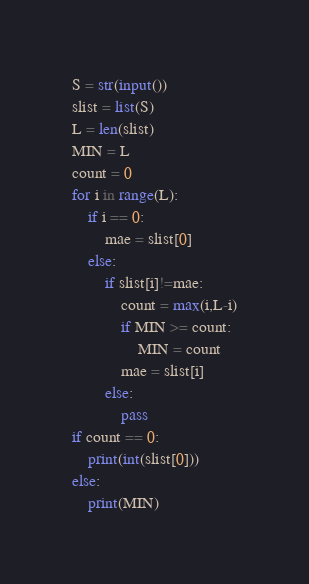Convert code to text. <code><loc_0><loc_0><loc_500><loc_500><_Python_>S = str(input())
slist = list(S)
L = len(slist)
MIN = L
count = 0
for i in range(L):
    if i == 0:
        mae = slist[0]
    else:
        if slist[i]!=mae:
            count = max(i,L-i)
            if MIN >= count:
                MIN = count
            mae = slist[i]
        else:
            pass
if count == 0:
    print(int(slist[0]))
else:
    print(MIN)
</code> 